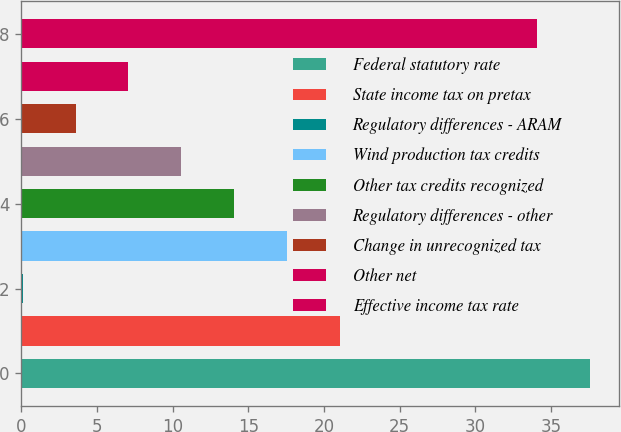Convert chart. <chart><loc_0><loc_0><loc_500><loc_500><bar_chart><fcel>Federal statutory rate<fcel>State income tax on pretax<fcel>Regulatory differences - ARAM<fcel>Wind production tax credits<fcel>Other tax credits recognized<fcel>Regulatory differences - other<fcel>Change in unrecognized tax<fcel>Other net<fcel>Effective income tax rate<nl><fcel>37.59<fcel>21.04<fcel>0.1<fcel>17.55<fcel>14.06<fcel>10.57<fcel>3.59<fcel>7.08<fcel>34.1<nl></chart> 